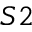Convert formula to latex. <formula><loc_0><loc_0><loc_500><loc_500>S 2</formula> 